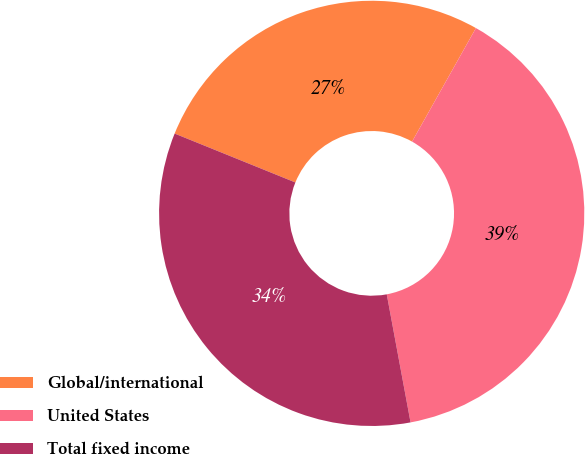Convert chart to OTSL. <chart><loc_0><loc_0><loc_500><loc_500><pie_chart><fcel>Global/international<fcel>United States<fcel>Total fixed income<nl><fcel>27.03%<fcel>38.92%<fcel>34.05%<nl></chart> 